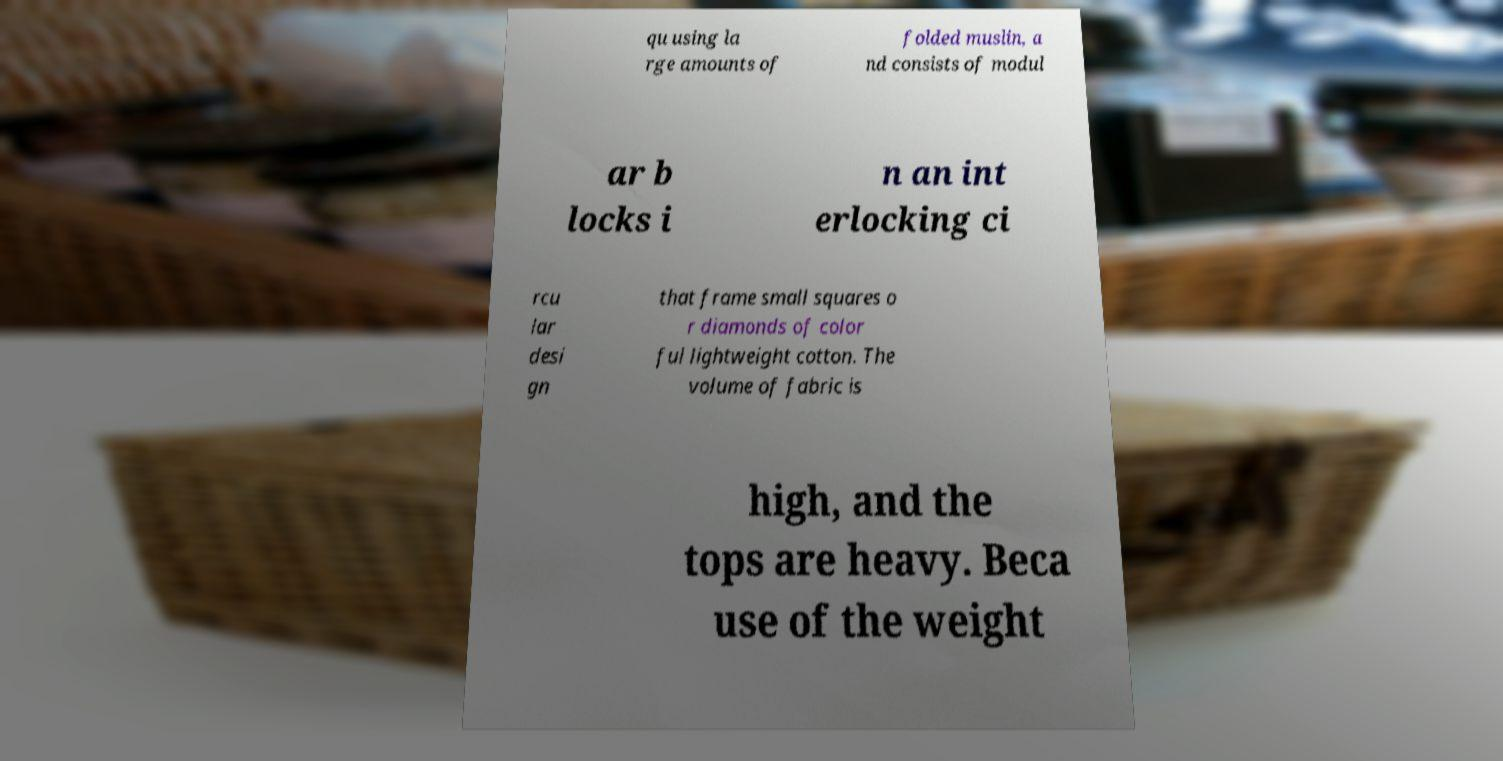Can you accurately transcribe the text from the provided image for me? qu using la rge amounts of folded muslin, a nd consists of modul ar b locks i n an int erlocking ci rcu lar desi gn that frame small squares o r diamonds of color ful lightweight cotton. The volume of fabric is high, and the tops are heavy. Beca use of the weight 